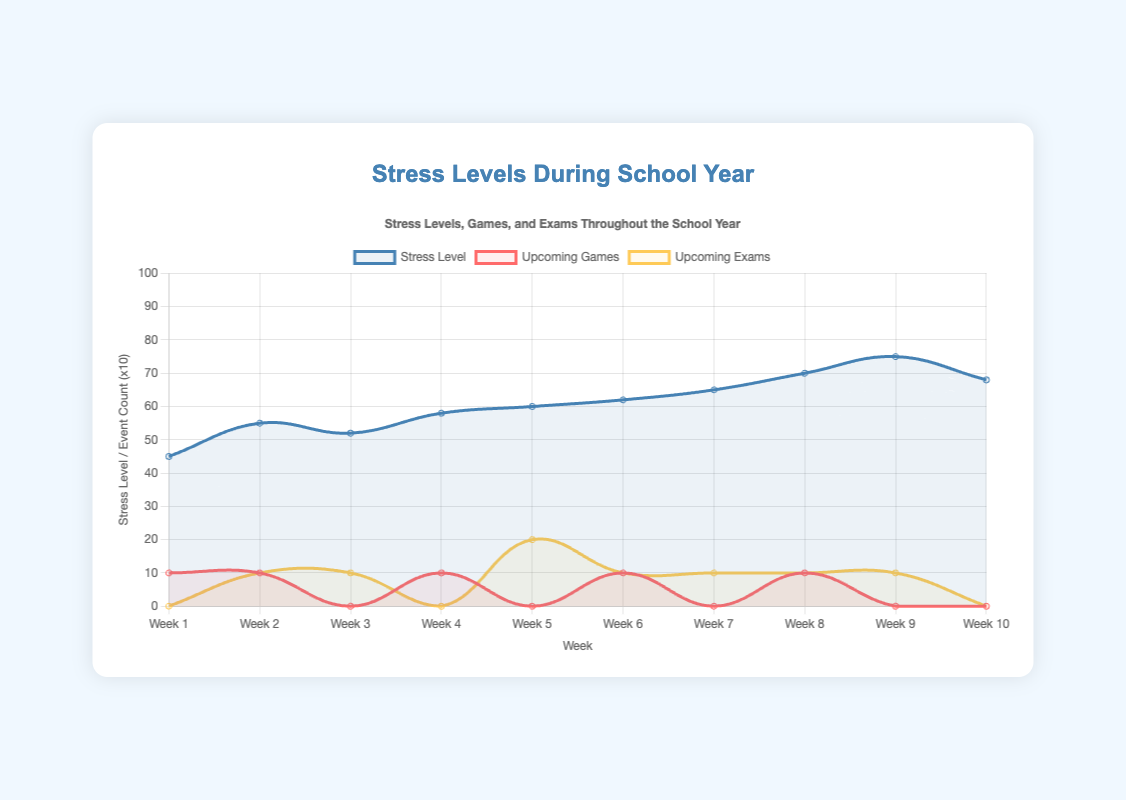What week shows the highest stress level? The highest stress level can be identified by observing the peak in the stress level line on the graph. Look for the highest point on the 'Stress Level' curve.
Answer: Week 9 On which week does the graph show a significant increase in stress level before a major school event? Look for a steep rise in the 'Stress Level' curve and then check the corresponding events annotated on the graph. You'll notice a significant increase before the "Final exams" in Week 9.
Answer: Week 8 How does the stress level change between the week of the important game against the rival school and the double exam week? Compare the stress levels between Week 4 and Week 5 by observing the values on the y-axis of the 'Stress Level' curve. Stress level changes from 58 to 60.
Answer: It increases by 2 points What is the average stress level over the first half of the data (Weeks 1-5)? Sum the stress levels for Weeks 1 through 5, then divide by 5. (45 + 55 + 52 + 58 + 60) / 5 = 54
Answer: 54 Which event causes the highest jump in stress level from one week to the next? Find the steepest incline on the 'Stress Level' curve. The sharpest increase is from Week 8 to Week 9, during "Season finale and final exam preparation" leading to "Final exams."
Answer: Final exams Between which two consecutive weeks is the stress level unchanged? Look at the 'Stress Level' curve for flat sections between two weeks. The stress level remains unchanged between Week 4 and Week 5.
Answer: None In which week does the stress level start to decline? Find the point where the 'Stress Level' curve starts to fall. This happens after Week 9.
Answer: Week 10 Which color represents upcoming exams on the chart? Identify the color of the line that follows the pattern of upcoming exams data points described. It is represented by a yellow shade.
Answer: Yellow How does the number of upcoming games affect stress levels based on the plot? Observe the correlation between peaks in the 'Upcoming Games' line and the 'Stress Level' curve. Higher stress levels often coincide with events involving games.
Answer: Games correlate with increased stress What is the sum of the stress levels during the weeks where there are no upcoming games? Sum stress levels for Weeks 3, 5, 7, and 9 where the upcoming games are 0. (52 + 60 + 65 + 75) = 252
Answer: 252 